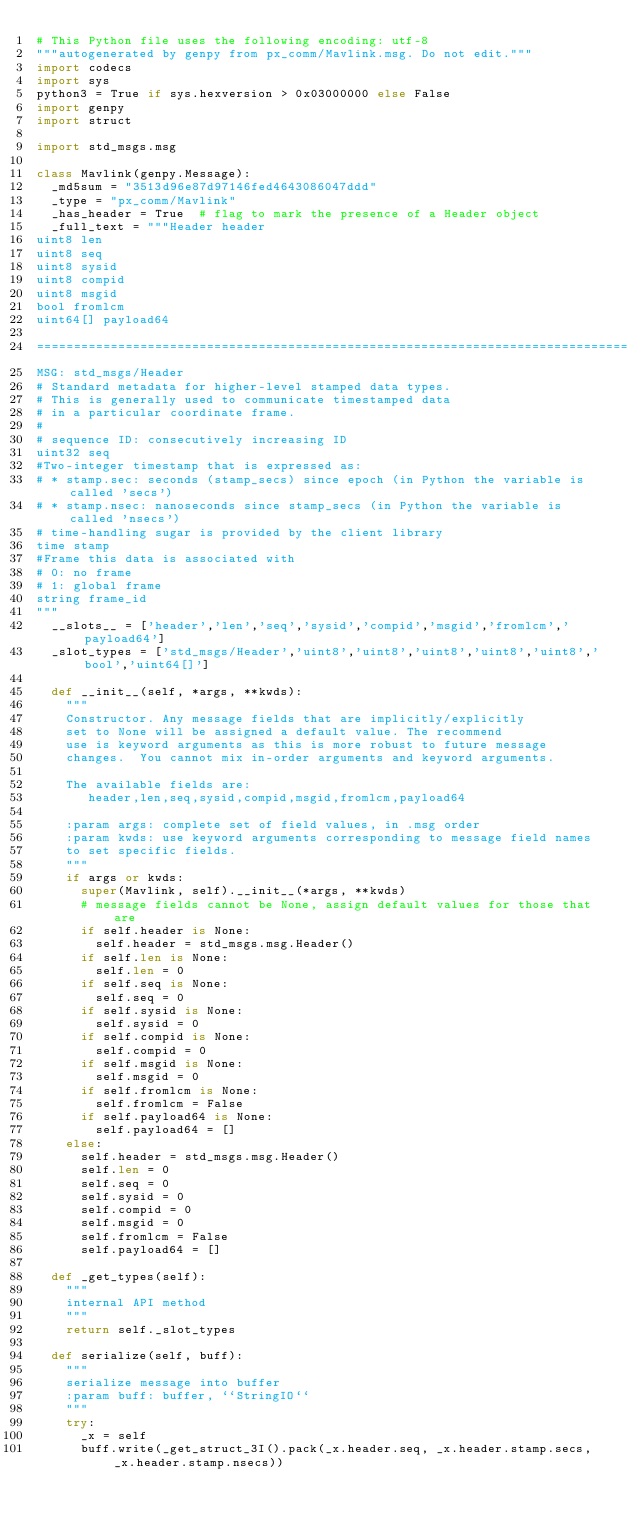Convert code to text. <code><loc_0><loc_0><loc_500><loc_500><_Python_># This Python file uses the following encoding: utf-8
"""autogenerated by genpy from px_comm/Mavlink.msg. Do not edit."""
import codecs
import sys
python3 = True if sys.hexversion > 0x03000000 else False
import genpy
import struct

import std_msgs.msg

class Mavlink(genpy.Message):
  _md5sum = "3513d96e87d97146fed4643086047ddd"
  _type = "px_comm/Mavlink"
  _has_header = True  # flag to mark the presence of a Header object
  _full_text = """Header header
uint8 len
uint8 seq
uint8 sysid
uint8 compid
uint8 msgid
bool fromlcm
uint64[] payload64

================================================================================
MSG: std_msgs/Header
# Standard metadata for higher-level stamped data types.
# This is generally used to communicate timestamped data 
# in a particular coordinate frame.
# 
# sequence ID: consecutively increasing ID 
uint32 seq
#Two-integer timestamp that is expressed as:
# * stamp.sec: seconds (stamp_secs) since epoch (in Python the variable is called 'secs')
# * stamp.nsec: nanoseconds since stamp_secs (in Python the variable is called 'nsecs')
# time-handling sugar is provided by the client library
time stamp
#Frame this data is associated with
# 0: no frame
# 1: global frame
string frame_id
"""
  __slots__ = ['header','len','seq','sysid','compid','msgid','fromlcm','payload64']
  _slot_types = ['std_msgs/Header','uint8','uint8','uint8','uint8','uint8','bool','uint64[]']

  def __init__(self, *args, **kwds):
    """
    Constructor. Any message fields that are implicitly/explicitly
    set to None will be assigned a default value. The recommend
    use is keyword arguments as this is more robust to future message
    changes.  You cannot mix in-order arguments and keyword arguments.

    The available fields are:
       header,len,seq,sysid,compid,msgid,fromlcm,payload64

    :param args: complete set of field values, in .msg order
    :param kwds: use keyword arguments corresponding to message field names
    to set specific fields.
    """
    if args or kwds:
      super(Mavlink, self).__init__(*args, **kwds)
      # message fields cannot be None, assign default values for those that are
      if self.header is None:
        self.header = std_msgs.msg.Header()
      if self.len is None:
        self.len = 0
      if self.seq is None:
        self.seq = 0
      if self.sysid is None:
        self.sysid = 0
      if self.compid is None:
        self.compid = 0
      if self.msgid is None:
        self.msgid = 0
      if self.fromlcm is None:
        self.fromlcm = False
      if self.payload64 is None:
        self.payload64 = []
    else:
      self.header = std_msgs.msg.Header()
      self.len = 0
      self.seq = 0
      self.sysid = 0
      self.compid = 0
      self.msgid = 0
      self.fromlcm = False
      self.payload64 = []

  def _get_types(self):
    """
    internal API method
    """
    return self._slot_types

  def serialize(self, buff):
    """
    serialize message into buffer
    :param buff: buffer, ``StringIO``
    """
    try:
      _x = self
      buff.write(_get_struct_3I().pack(_x.header.seq, _x.header.stamp.secs, _x.header.stamp.nsecs))</code> 